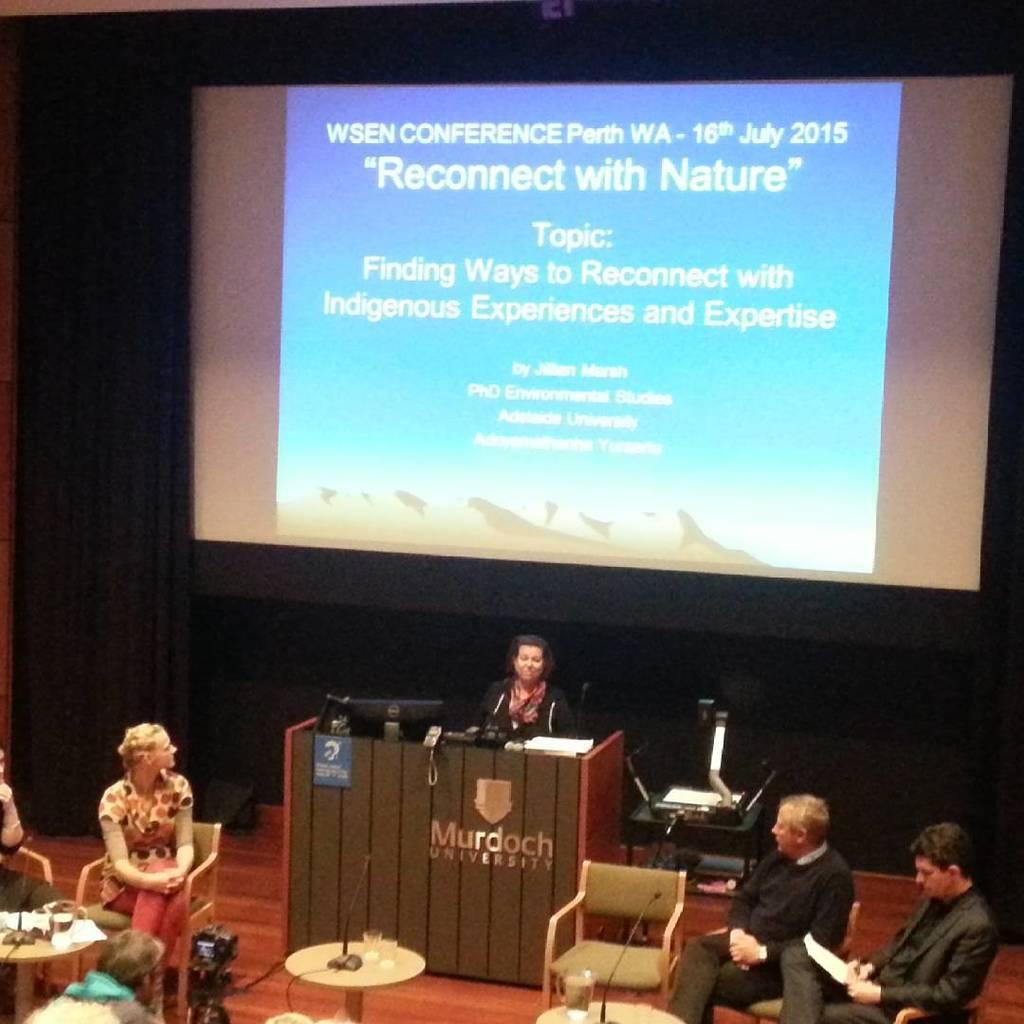Please provide a concise description of this image. In this picture there are group of people sitting here and discussing and in the background there is a projector screen 